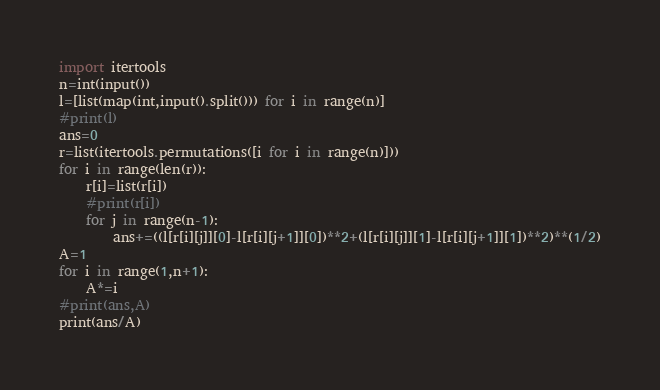<code> <loc_0><loc_0><loc_500><loc_500><_Python_>import itertools
n=int(input())
l=[list(map(int,input().split())) for i in range(n)]
#print(l)
ans=0
r=list(itertools.permutations([i for i in range(n)]))
for i in range(len(r)):
    r[i]=list(r[i])
    #print(r[i])
    for j in range(n-1):
        ans+=((l[r[i][j]][0]-l[r[i][j+1]][0])**2+(l[r[i][j]][1]-l[r[i][j+1]][1])**2)**(1/2)
A=1
for i in range(1,n+1):
    A*=i
#print(ans,A)
print(ans/A)</code> 